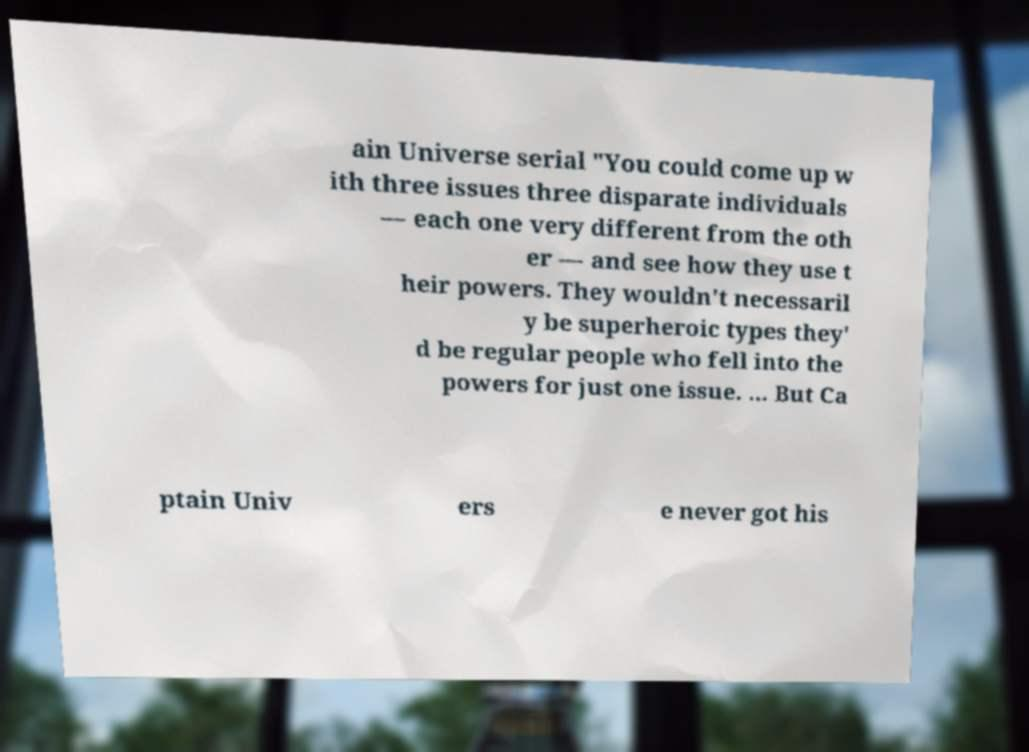Please read and relay the text visible in this image. What does it say? ain Universe serial "You could come up w ith three issues three disparate individuals — each one very different from the oth er — and see how they use t heir powers. They wouldn't necessaril y be superheroic types they' d be regular people who fell into the powers for just one issue. ... But Ca ptain Univ ers e never got his 